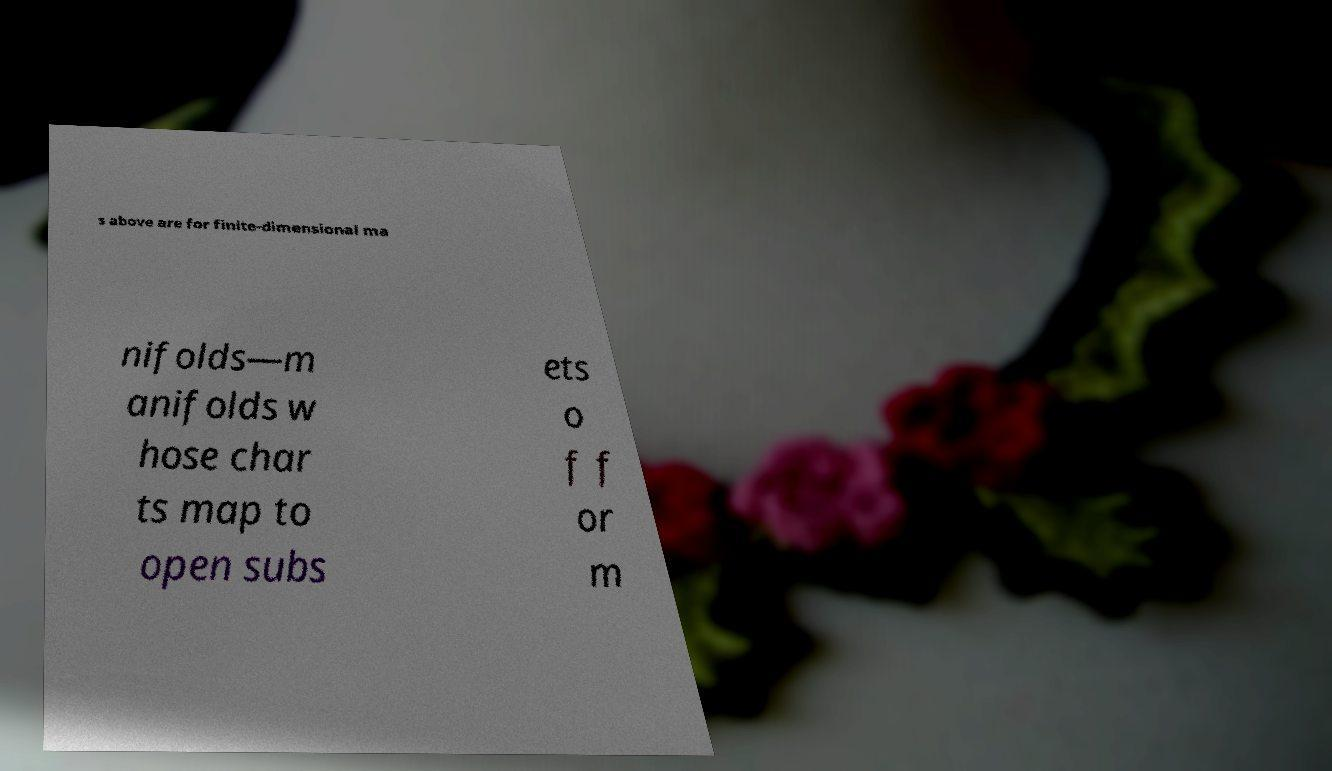Can you accurately transcribe the text from the provided image for me? s above are for finite-dimensional ma nifolds—m anifolds w hose char ts map to open subs ets o f f or m 